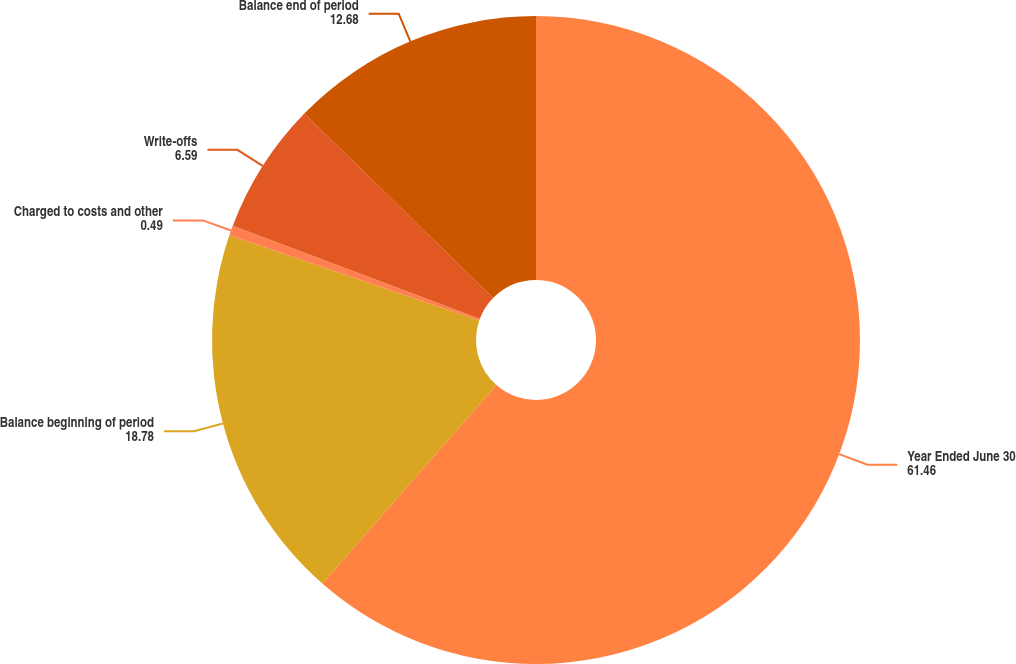Convert chart to OTSL. <chart><loc_0><loc_0><loc_500><loc_500><pie_chart><fcel>Year Ended June 30<fcel>Balance beginning of period<fcel>Charged to costs and other<fcel>Write-offs<fcel>Balance end of period<nl><fcel>61.46%<fcel>18.78%<fcel>0.49%<fcel>6.59%<fcel>12.68%<nl></chart> 